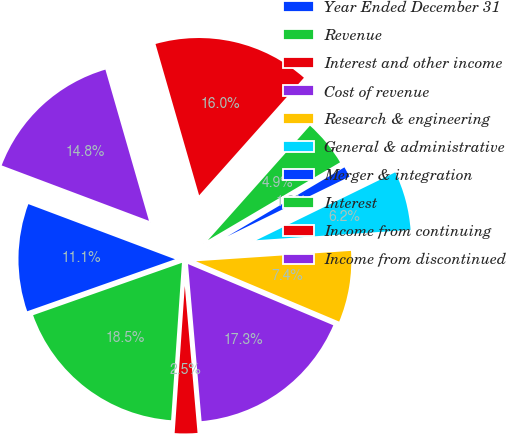Convert chart. <chart><loc_0><loc_0><loc_500><loc_500><pie_chart><fcel>Year Ended December 31<fcel>Revenue<fcel>Interest and other income<fcel>Cost of revenue<fcel>Research & engineering<fcel>General & administrative<fcel>Merger & integration<fcel>Interest<fcel>Income from continuing<fcel>Income from discontinued<nl><fcel>11.11%<fcel>18.52%<fcel>2.47%<fcel>17.28%<fcel>7.41%<fcel>6.17%<fcel>1.24%<fcel>4.94%<fcel>16.05%<fcel>14.81%<nl></chart> 